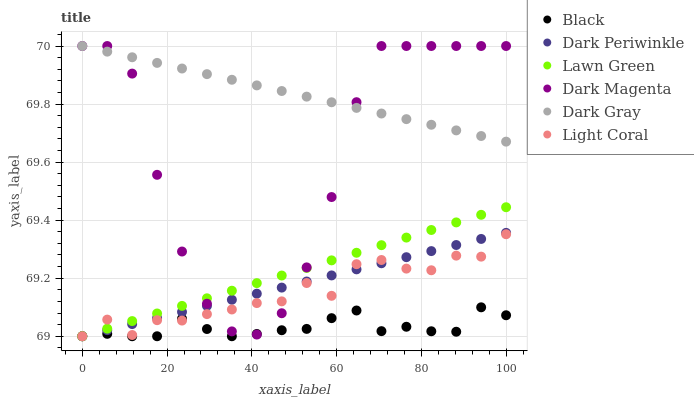Does Black have the minimum area under the curve?
Answer yes or no. Yes. Does Dark Gray have the maximum area under the curve?
Answer yes or no. Yes. Does Dark Magenta have the minimum area under the curve?
Answer yes or no. No. Does Dark Magenta have the maximum area under the curve?
Answer yes or no. No. Is Dark Gray the smoothest?
Answer yes or no. Yes. Is Dark Magenta the roughest?
Answer yes or no. Yes. Is Light Coral the smoothest?
Answer yes or no. No. Is Light Coral the roughest?
Answer yes or no. No. Does Lawn Green have the lowest value?
Answer yes or no. Yes. Does Dark Magenta have the lowest value?
Answer yes or no. No. Does Dark Gray have the highest value?
Answer yes or no. Yes. Does Light Coral have the highest value?
Answer yes or no. No. Is Dark Periwinkle less than Dark Gray?
Answer yes or no. Yes. Is Dark Gray greater than Lawn Green?
Answer yes or no. Yes. Does Black intersect Light Coral?
Answer yes or no. Yes. Is Black less than Light Coral?
Answer yes or no. No. Is Black greater than Light Coral?
Answer yes or no. No. Does Dark Periwinkle intersect Dark Gray?
Answer yes or no. No. 